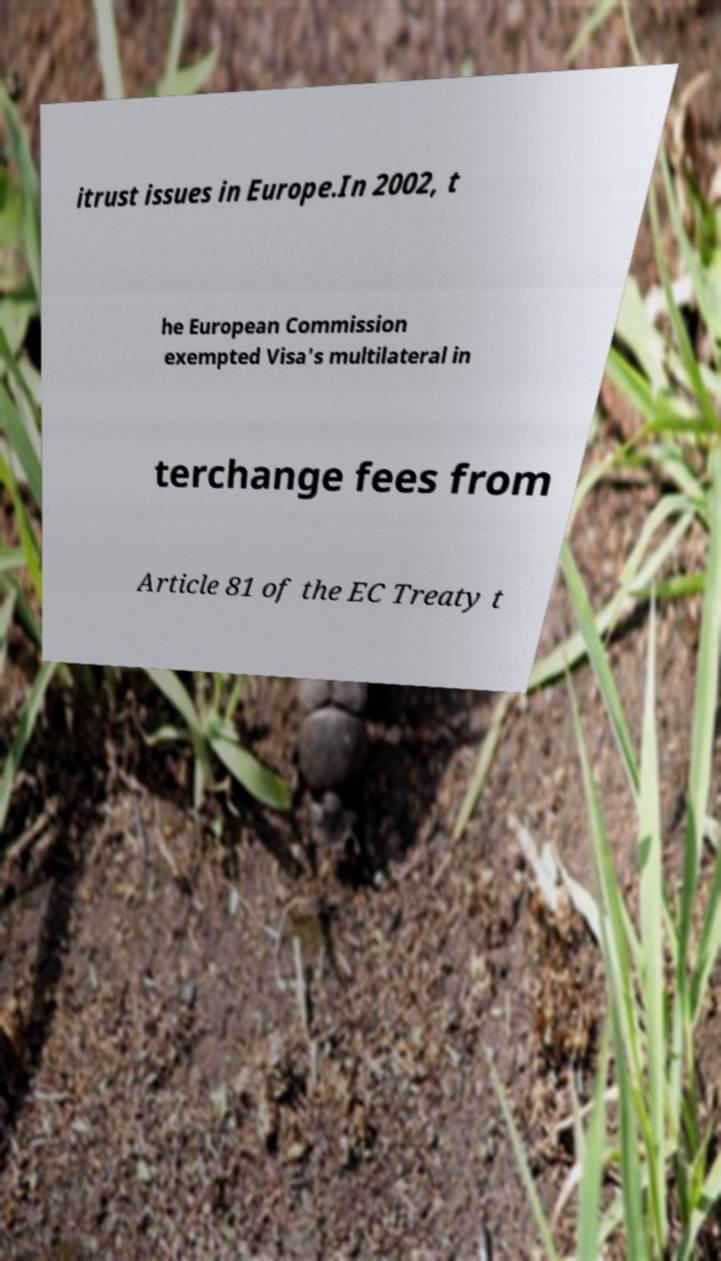Please identify and transcribe the text found in this image. itrust issues in Europe.In 2002, t he European Commission exempted Visa's multilateral in terchange fees from Article 81 of the EC Treaty t 